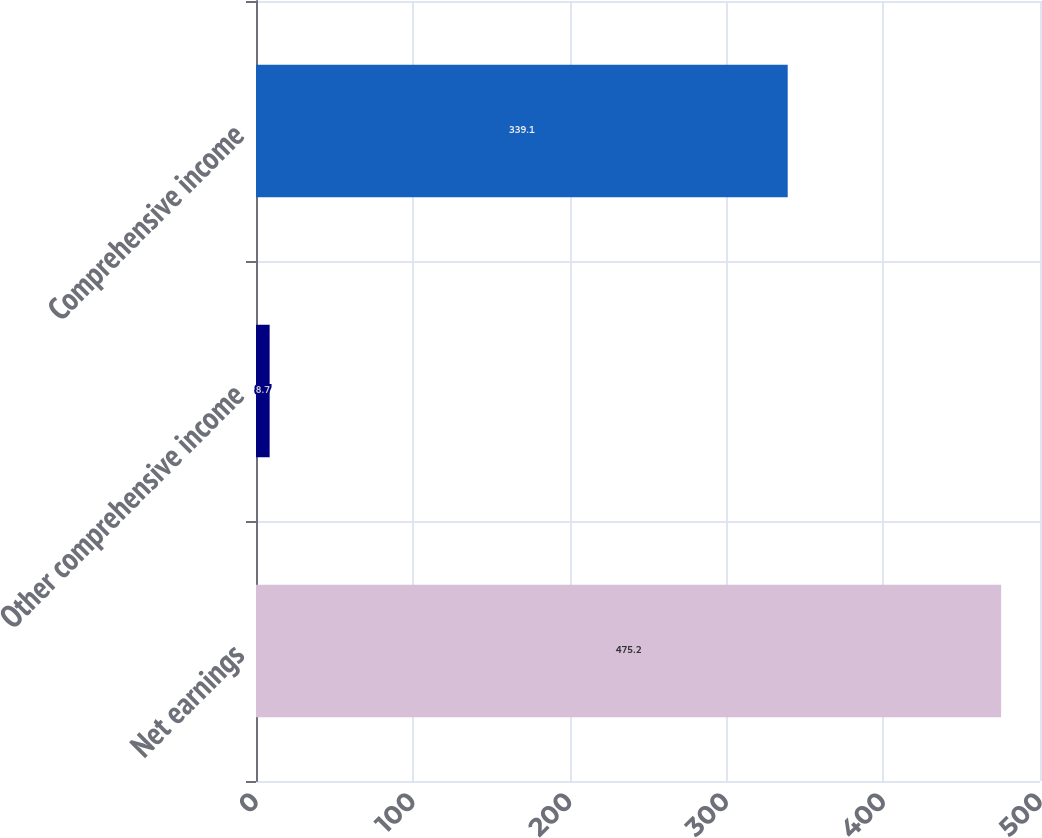<chart> <loc_0><loc_0><loc_500><loc_500><bar_chart><fcel>Net earnings<fcel>Other comprehensive income<fcel>Comprehensive income<nl><fcel>475.2<fcel>8.7<fcel>339.1<nl></chart> 